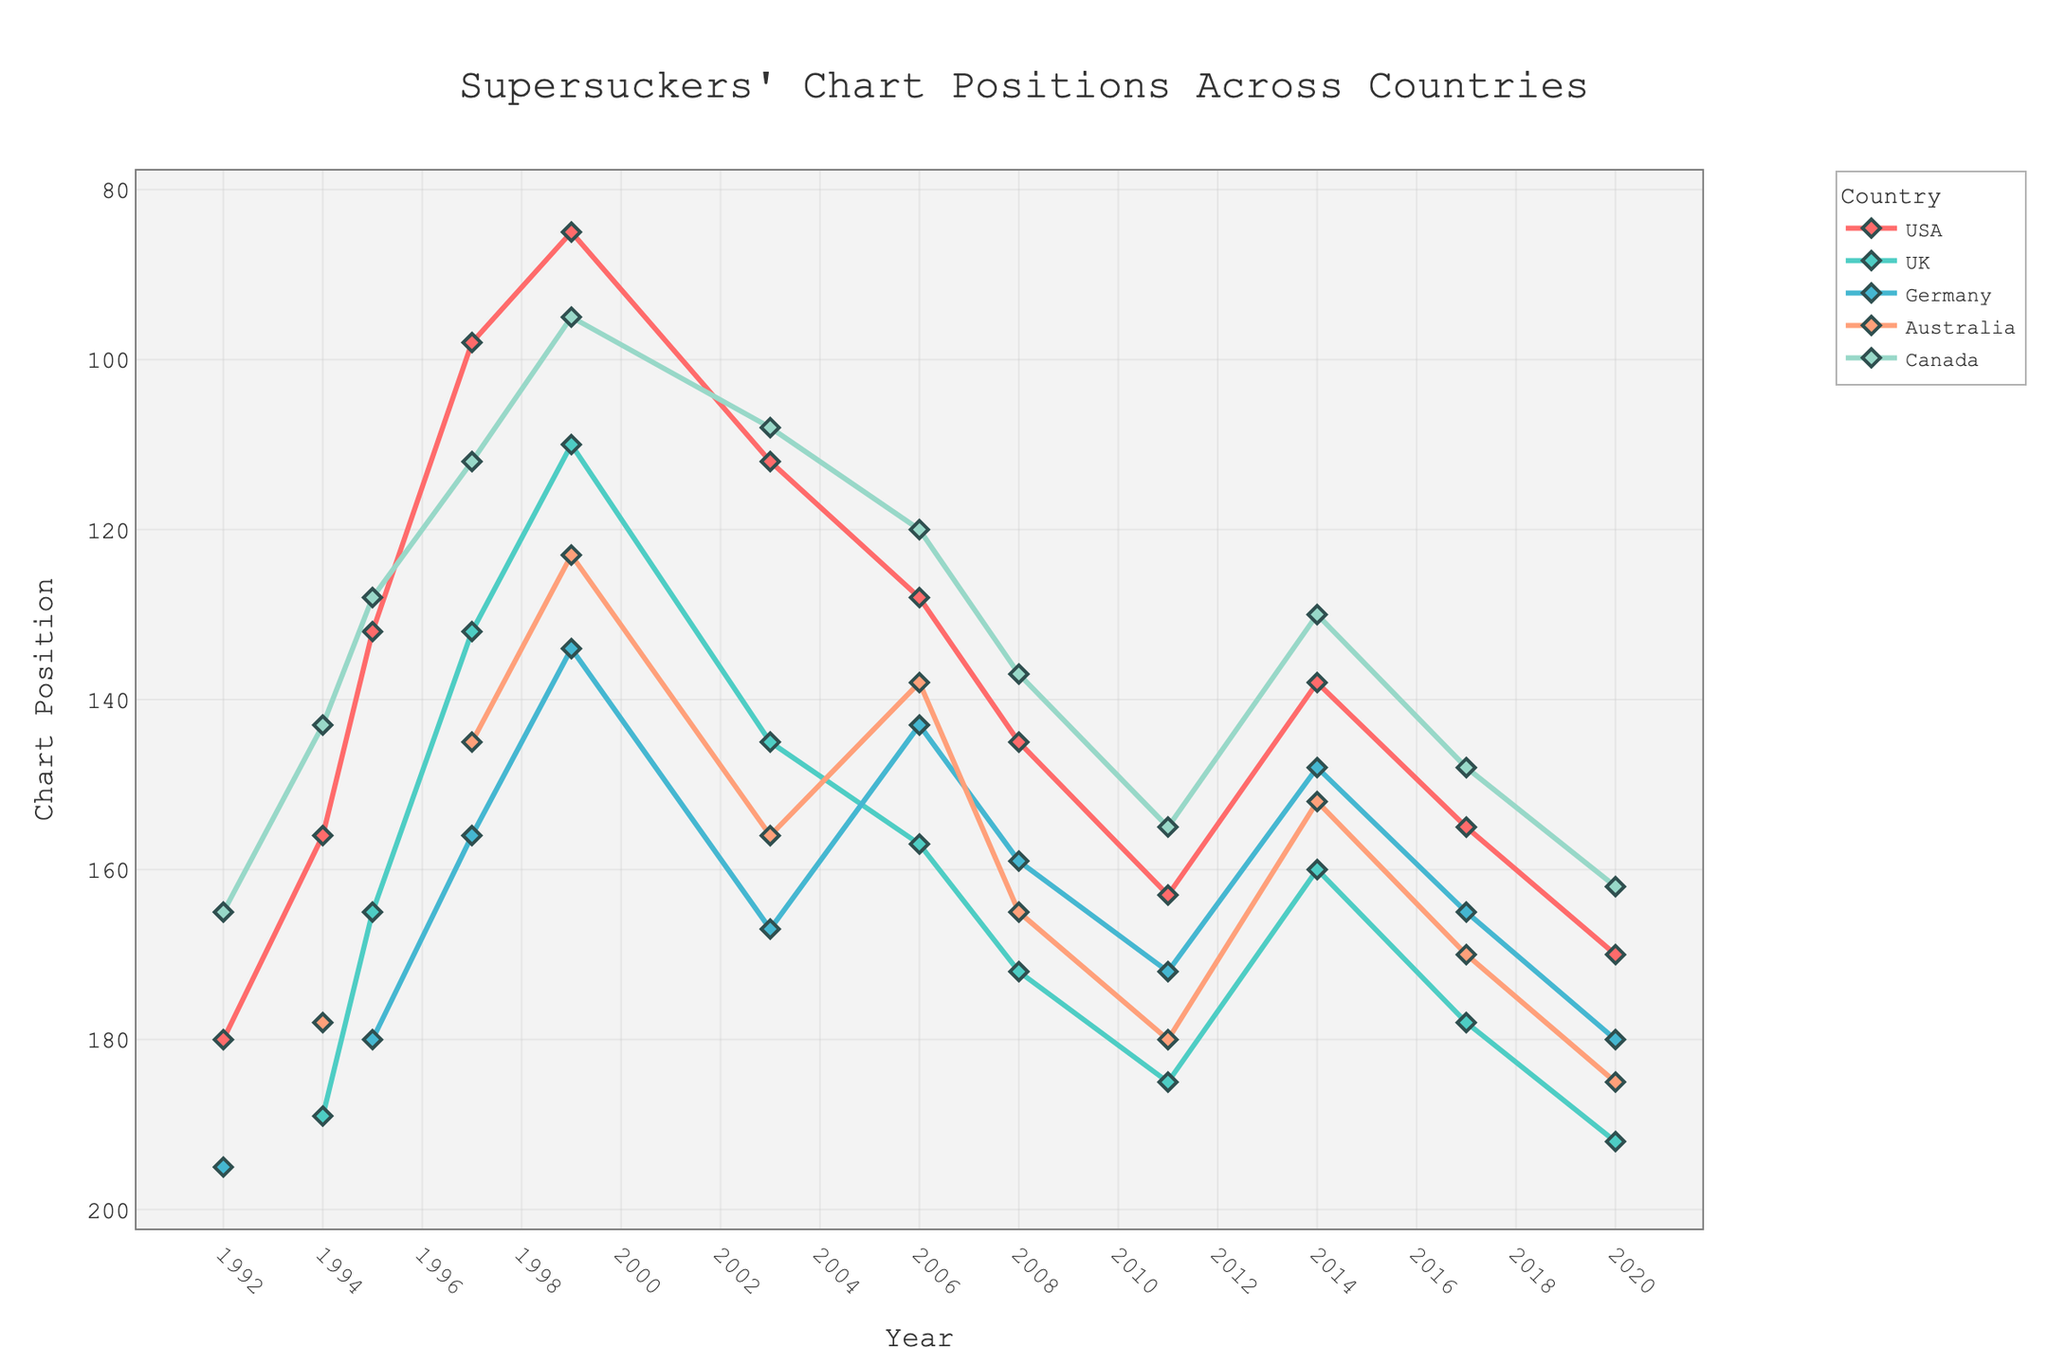What was the highest chart position the Supersuckers achieved in Germany? Look at the line representing Germany across different years, identify the lowest point (because the y-axis for chart positions is reversed), which occurred in 1995 at position 180.
Answer: 180 Which country had the highest chart position for the Supersuckers in 1997? Compare the chart positions of the five countries in 1997. The lowest number indicates the highest chart position due to the reversed y-axis. The USA's position is 98, which is the lowest value among all countries.
Answer: USA How did the Supersuckers' chart positions in the USA change from 1999 to 2006? Track the USA line from 1999 (position 85) to 2006 (position 128). The position increased, indicating a decline in chart ranking.
Answer: Declined In which year did Australia see the highest chart position for the Supersuckers, and what was that position? Examine the line representing Australia. The lowest position (highest rank) is in 1999 at position 123.
Answer: 1999, 123 Between 1995 and 2014, how many times did the Supersuckers chart in the UK? Check the UK line between 1995 and 2014. They charted five times (1995, 1997, 1999, 2003, 2006, 2008, 2011, and 2014).
Answer: 8 What was the average chart position in Canada from 1994 to 2020? Identify the positions in Canada from 1994 to 2020 and calculate their average: (143 + 128 + 112 + 95 + 108 + 120 + 137 + 155 + 130 + 148 + 162) / 11 = 133.55.
Answer: 133.55 Which year saw the largest decline in chart position in the UK? Look at the UK line for the steepest increase in position number (which indicates a decline due to the reversed y-axis). The largest decline is between 2017 (178) and 2020 (192), a drop of 14 positions.
Answer: 2020 Over their career, in which country did the Supersuckers have the highest variation in chart positions? Evaluate the range of chart positions for each line. The UK line varies from 110 to 192, which is the broadest range.
Answer: UK What is the overall trend in the Supersuckers' chart positions in Germany from 2003 to 2020? Follow the Germany line from 2003 (167) to 2020 (180). The chart position number increases, indicating a decline in rank.
Answer: Declining Compare the chart positions of the Supersuckers in Australia and Canada in 2011. Which country had a better chart position? Compare the positions in 2011: Australia (180) and Canada (155). Lower numbers indicate better positions, so Canada had a better chart position.
Answer: Canada 